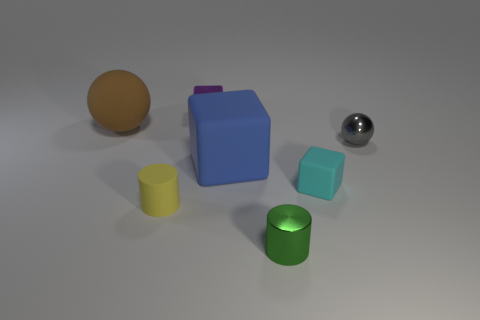Can you describe the overall atmosphere or theme presented by the objects and their arrangement? The overall atmosphere suggests a staged arrangement for a study in color, form, and material. There is a sense of simplicity and order, giving it an almost clinical or educational presentation theme. 